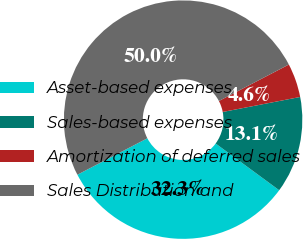Convert chart. <chart><loc_0><loc_0><loc_500><loc_500><pie_chart><fcel>Asset-based expenses<fcel>Sales-based expenses<fcel>Amortization of deferred sales<fcel>Sales Distribution and<nl><fcel>32.27%<fcel>13.13%<fcel>4.6%<fcel>50.0%<nl></chart> 